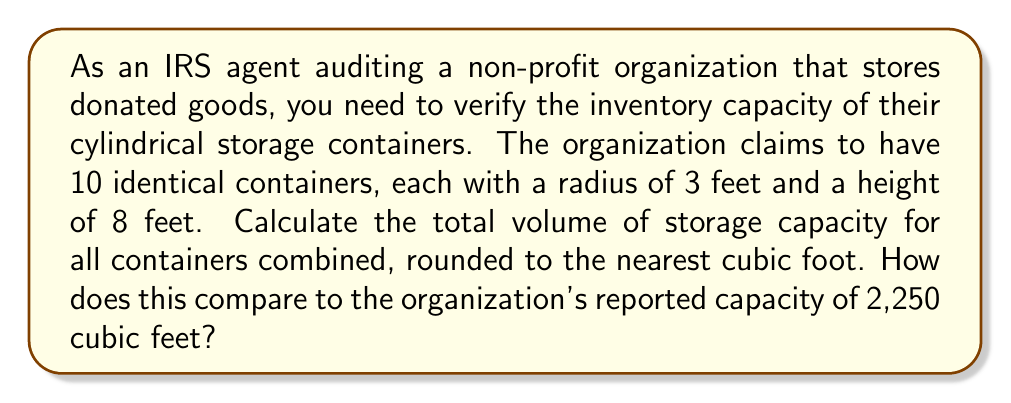Can you solve this math problem? To solve this problem, we need to follow these steps:

1. Calculate the volume of a single cylindrical container:
   The volume of a cylinder is given by the formula:
   $$V = \pi r^2 h$$
   where $r$ is the radius and $h$ is the height.

2. Substitute the given values:
   $$V = \pi \cdot (3\text{ ft})^2 \cdot (8\text{ ft})$$

3. Calculate:
   $$V = \pi \cdot 9\text{ ft}^2 \cdot 8\text{ ft}$$
   $$V = 72\pi\text{ ft}^3$$
   $$V \approx 226.19\text{ ft}^3$$

4. Round to the nearest cubic foot:
   $$V \approx 226\text{ ft}^3$$

5. Multiply by the number of containers:
   Total volume = $226\text{ ft}^3 \cdot 10 = 2,260\text{ ft}^3$

6. Compare with the reported capacity:
   Actual capacity: 2,260 ft³
   Reported capacity: 2,250 ft³
   Difference: $2,260 - 2,250 = 10\text{ ft}^3$

The actual capacity exceeds the reported capacity by 10 cubic feet.

[asy]
import geometry;

size(200);
real r = 3;
real h = 8;
pair O = (0,0);

draw(circle(O, r));
draw((r,0)--(r,h));
draw((-r,0)--(-r,h));
draw(circle((0,h), r));
draw(O--(r,0), dashed);
draw((0,h/2)--(r,h/2), Arrow);

label("r", (r/2,h/2), E);
label("h", (r,h/2), E);

[/asy]
Answer: The total volume of storage capacity for all 10 containers is 2,260 cubic feet, which is 10 cubic feet more than the reported capacity of 2,250 cubic feet. 